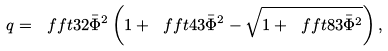<formula> <loc_0><loc_0><loc_500><loc_500>q = \ f f t 3 { 2 \bar { \Phi } ^ { 2 } } \left ( 1 + \ f f t 4 3 \bar { \Phi } ^ { 2 } - \sqrt { 1 + \ f f t 8 3 \bar { \Phi } ^ { 2 } } \right ) ,</formula> 